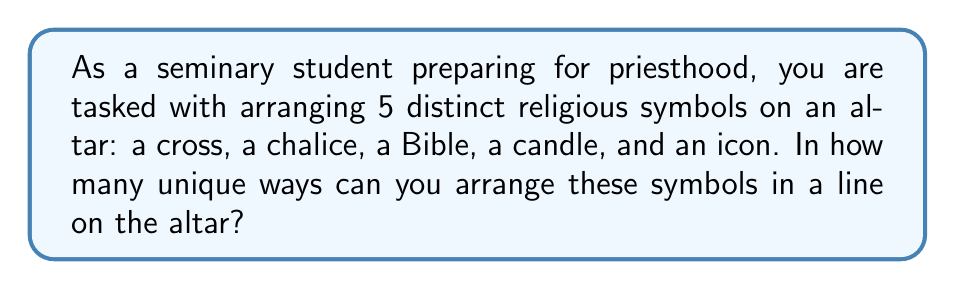Help me with this question. Let's approach this step-by-step:

1) This is a permutation problem. We are arranging all 5 symbols, and the order matters.

2) The formula for permutations of n distinct objects is:

   $$P(n) = n!$$

   Where $n!$ represents the factorial of n.

3) In this case, we have 5 distinct symbols, so $n = 5$.

4) Let's calculate $5!$:

   $$5! = 5 \times 4 \times 3 \times 2 \times 1 = 120$$

5) This means there are 120 unique ways to arrange the 5 religious symbols.

To visualize this, we can think of it as:
- We have 5 choices for the first position
- Then 4 choices for the second position
- 3 for the third
- 2 for the fourth
- And only 1 choice left for the last position

$$5 \times 4 \times 3 \times 2 \times 1 = 120$$

This multiplication principle leads us to the same result as the factorial calculation.
Answer: 120 